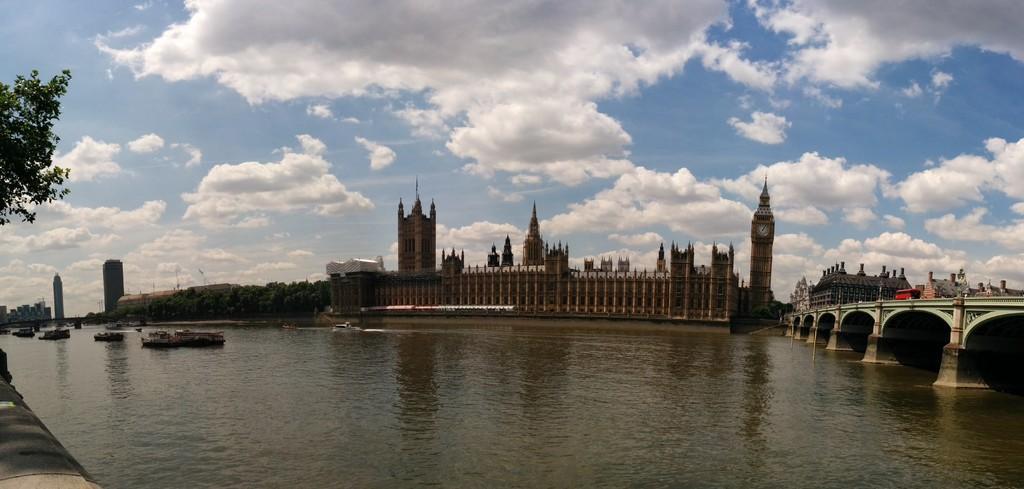Describe this image in one or two sentences. In this image we can see the lake, ships, trees, there is a bridge and few vehicles, we can see the buildings in the background, at the top we can see the sky with clouds. 